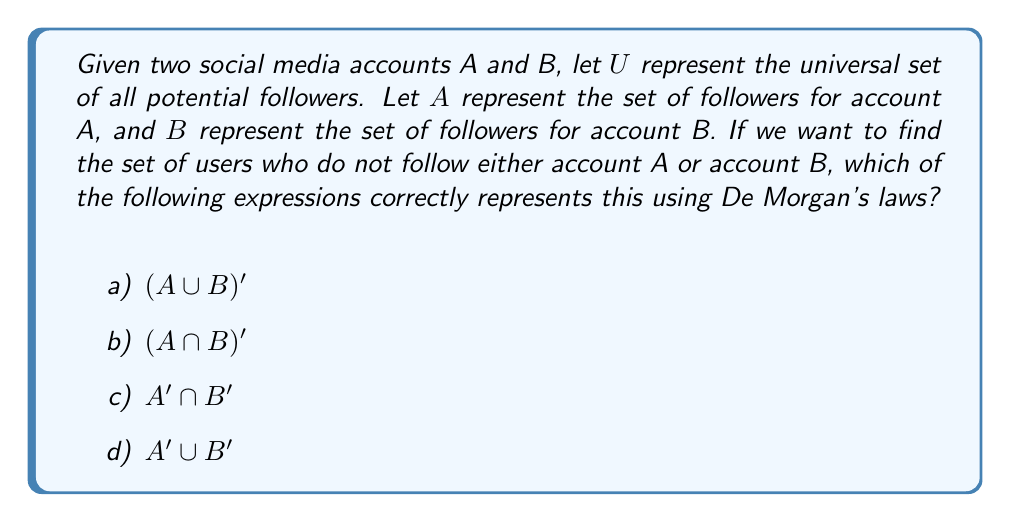Can you answer this question? Let's approach this step-by-step:

1) We want to find users who do not follow either account A or account B. In set theory, this is equivalent to finding the complement of the union of A and B.

2) Mathematically, this can be expressed as $(A \cup B)'$, where the prime symbol (') denotes the complement.

3) According to De Morgan's laws, for any two sets X and Y:

   $$(X \cup Y)' = X' \cap Y'$$

4) Applying this to our problem:

   $$(A \cup B)' = A' \cap B'$$

5) This means that the set of users who do not follow either account A or account B is equal to the intersection of users who don't follow A and users who don't follow B.

6) Looking at our options:
   a) $(A \cup B)'$ is the initial expression we're trying to simplify.
   b) $(A \cap B)'$ represents users who don't follow both A and B, which is not what we're looking for.
   c) $A' \cap B'$ is the correct simplification according to De Morgan's laws.
   d) $A' \cup B'$ represents users who don't follow A or don't follow B, which is not equivalent to our desired set.

Therefore, the correct answer is c) $A' \cap B'$.
Answer: c) $A' \cap B'$ 